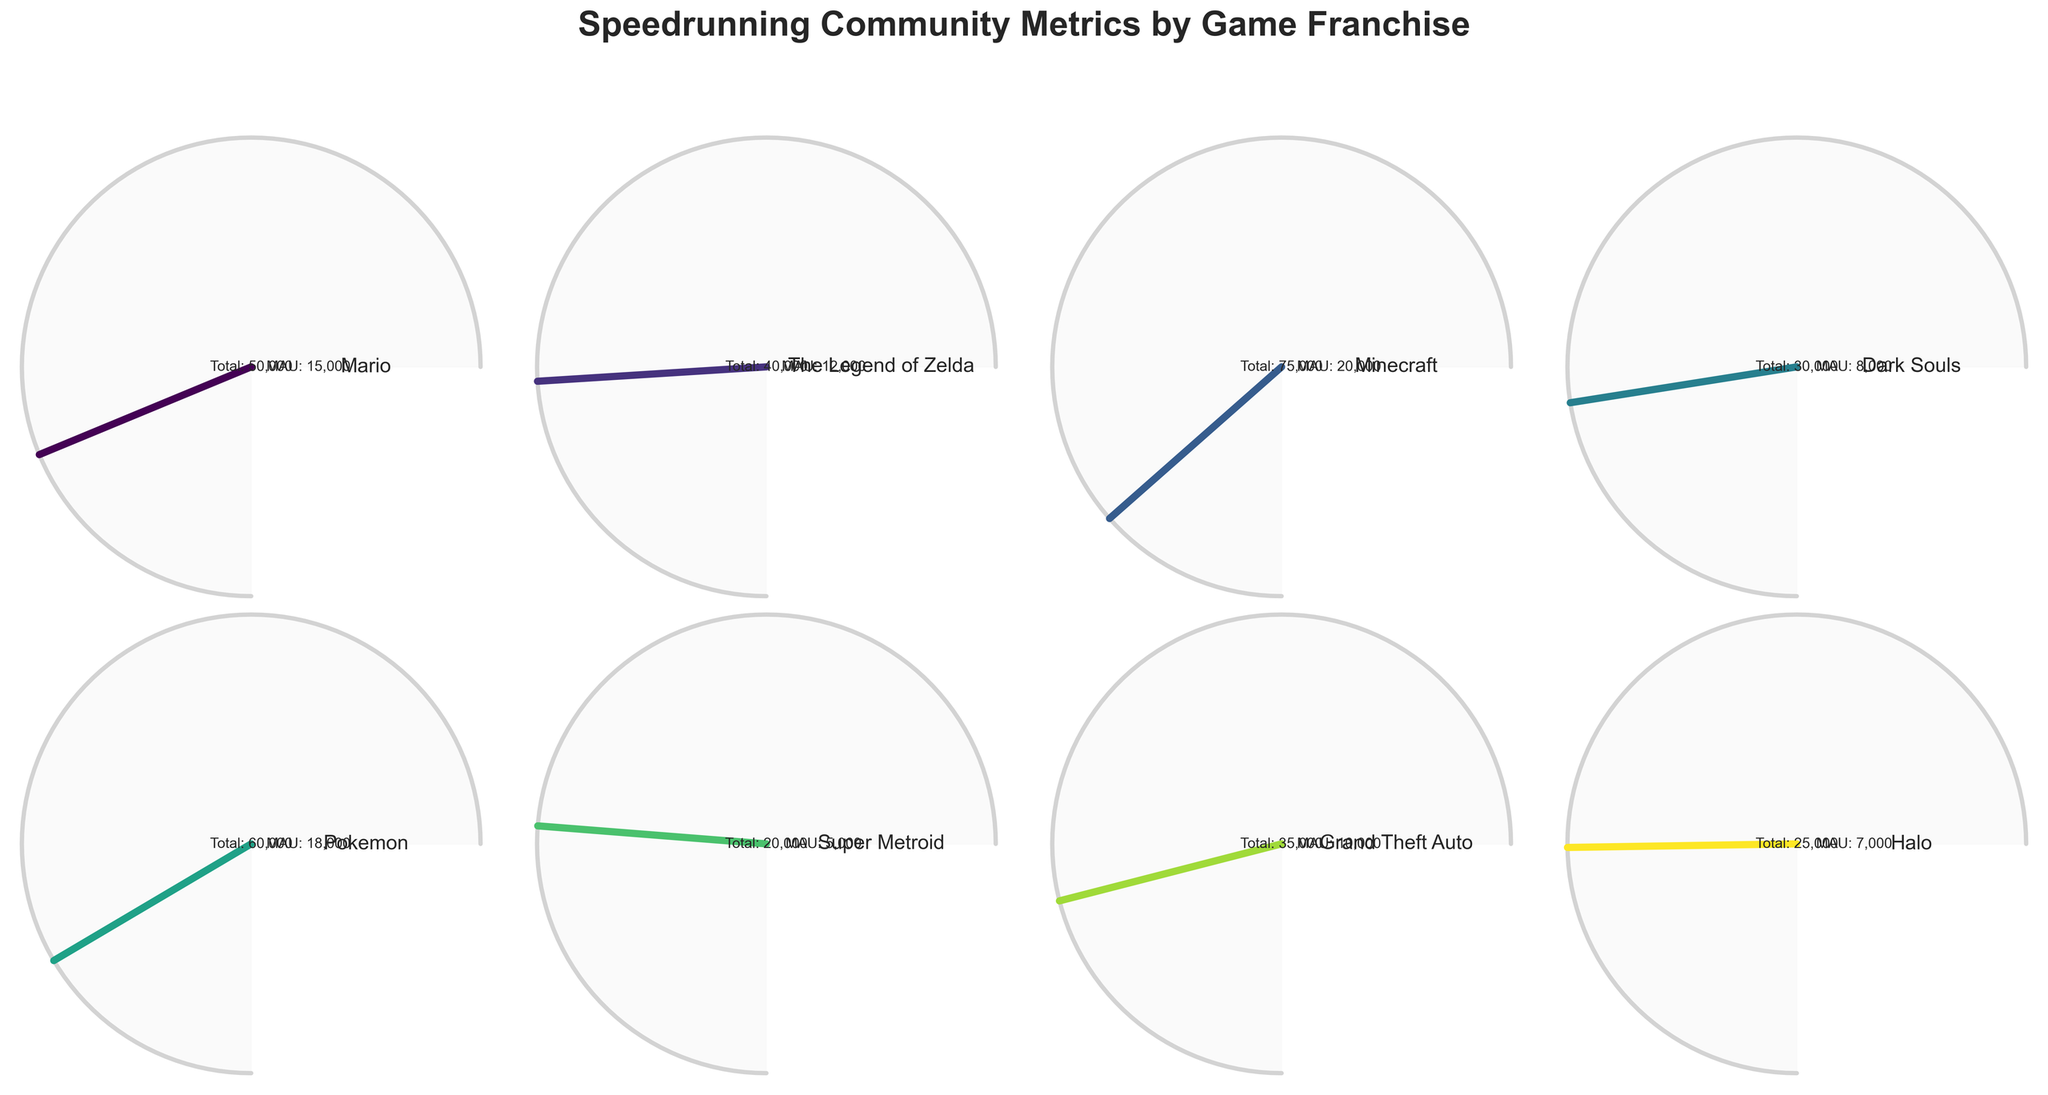What's the title of the figure? The title is displayed at the top of the figure, written in bold font.
Answer: Speedrunning Community Metrics by Game Franchise Which game franchise has the highest engagement rate? The gauge with the highest value reading on the engagement scale indicates the highest engagement rate.
Answer: Minecraft What is the engagement rate for the Grand Theft Auto franchise? Look for the gauge labeled "Grand Theft Auto" and read the engagement percentage displayed below it.
Answer: 72% How many total members does the Halo franchise have? The total members for each franchise are labeled inside the gauge; look for "Total" underneath the game title "Halo."
Answer: 25,000 What's the difference in monthly active users between Dark Souls and Pokemon? Subtract the monthly active users of Dark Souls (8,000) from the monthly active users of Pokemon (18,000).
Answer: 10,000 Which game franchise has more monthly active users, Mario or The Legend of Zelda? Compare the monthly active users labeled in the gauges for Mario (15,000) and The Legend of Zelda (12,000).
Answer: Mario What is the average engagement rate of all the displayed game franchises? Sum all engagement rates: (75% + 68% + 82% + 70% + 78% + 65% + 72% + 67%) = 577%. Then divide by the number of franchises (8).
Answer: 72.125% Which game franchise has the lowest engagement rate? The gauge with the lowest value reading on the engagement scale indicates the lowest engagement rate.
Answer: Super Metroid What is the combined number of total members for the Mario and Minecraft franchises? Add the total members of Mario (50,000) and Minecraft (75,000).
Answer: 125,000 Does the engagement rate for Pokemon exceed that of Mario? Compare the engagement rates of Pokemon (78%) and Mario (75%).
Answer: Yes 